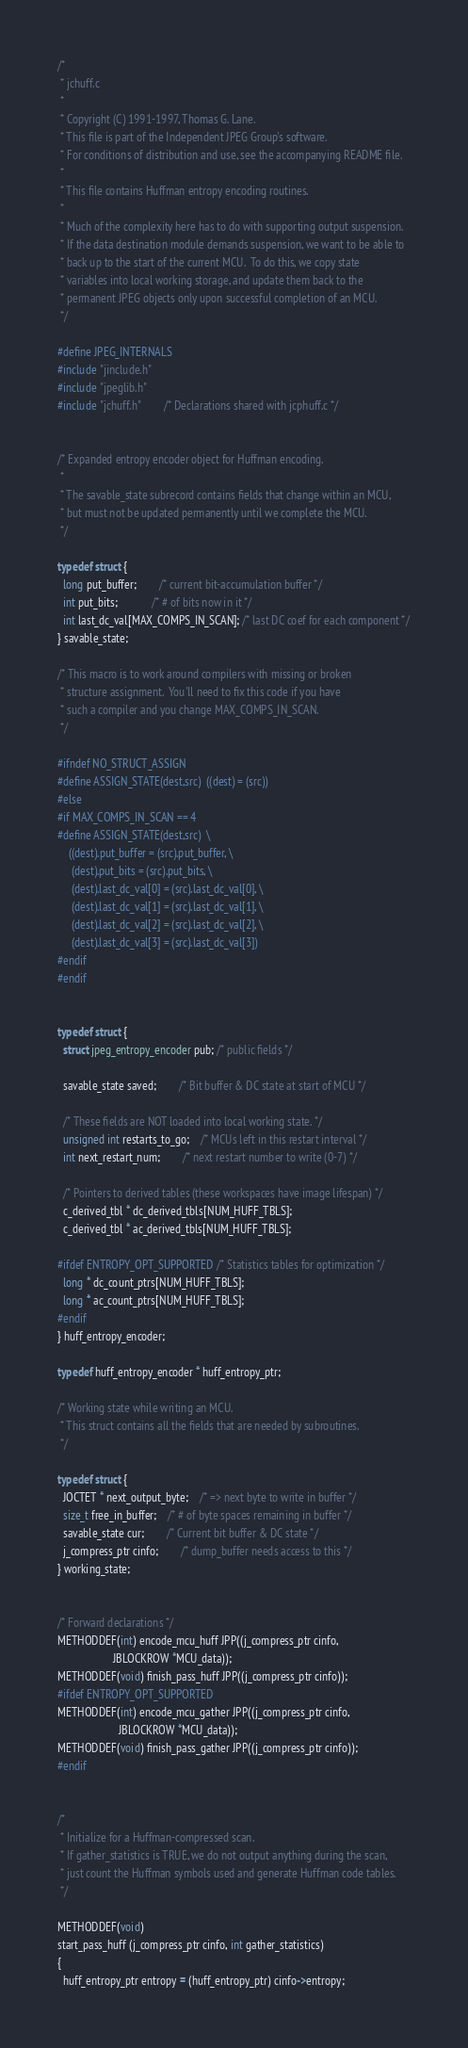<code> <loc_0><loc_0><loc_500><loc_500><_C++_>/*
 * jchuff.c
 *
 * Copyright (C) 1991-1997, Thomas G. Lane.
 * This file is part of the Independent JPEG Group's software.
 * For conditions of distribution and use, see the accompanying README file.
 *
 * This file contains Huffman entropy encoding routines.
 *
 * Much of the complexity here has to do with supporting output suspension.
 * If the data destination module demands suspension, we want to be able to
 * back up to the start of the current MCU.  To do this, we copy state
 * variables into local working storage, and update them back to the
 * permanent JPEG objects only upon successful completion of an MCU.
 */

#define JPEG_INTERNALS
#include "jinclude.h"
#include "jpeglib.h"
#include "jchuff.h"		/* Declarations shared with jcphuff.c */


/* Expanded entropy encoder object for Huffman encoding.
 *
 * The savable_state subrecord contains fields that change within an MCU,
 * but must not be updated permanently until we complete the MCU.
 */

typedef struct {
  long put_buffer;		/* current bit-accumulation buffer */
  int put_bits;			/* # of bits now in it */
  int last_dc_val[MAX_COMPS_IN_SCAN]; /* last DC coef for each component */
} savable_state;

/* This macro is to work around compilers with missing or broken
 * structure assignment.  You'll need to fix this code if you have
 * such a compiler and you change MAX_COMPS_IN_SCAN.
 */

#ifndef NO_STRUCT_ASSIGN
#define ASSIGN_STATE(dest,src)  ((dest) = (src))
#else
#if MAX_COMPS_IN_SCAN == 4
#define ASSIGN_STATE(dest,src)  \
	((dest).put_buffer = (src).put_buffer, \
	 (dest).put_bits = (src).put_bits, \
	 (dest).last_dc_val[0] = (src).last_dc_val[0], \
	 (dest).last_dc_val[1] = (src).last_dc_val[1], \
	 (dest).last_dc_val[2] = (src).last_dc_val[2], \
	 (dest).last_dc_val[3] = (src).last_dc_val[3])
#endif
#endif


typedef struct {
  struct jpeg_entropy_encoder pub; /* public fields */

  savable_state saved;		/* Bit buffer & DC state at start of MCU */

  /* These fields are NOT loaded into local working state. */
  unsigned int restarts_to_go;	/* MCUs left in this restart interval */
  int next_restart_num;		/* next restart number to write (0-7) */

  /* Pointers to derived tables (these workspaces have image lifespan) */
  c_derived_tbl * dc_derived_tbls[NUM_HUFF_TBLS];
  c_derived_tbl * ac_derived_tbls[NUM_HUFF_TBLS];

#ifdef ENTROPY_OPT_SUPPORTED	/* Statistics tables for optimization */
  long * dc_count_ptrs[NUM_HUFF_TBLS];
  long * ac_count_ptrs[NUM_HUFF_TBLS];
#endif
} huff_entropy_encoder;

typedef huff_entropy_encoder * huff_entropy_ptr;

/* Working state while writing an MCU.
 * This struct contains all the fields that are needed by subroutines.
 */

typedef struct {
  JOCTET * next_output_byte;	/* => next byte to write in buffer */
  size_t free_in_buffer;	/* # of byte spaces remaining in buffer */
  savable_state cur;		/* Current bit buffer & DC state */
  j_compress_ptr cinfo;		/* dump_buffer needs access to this */
} working_state;


/* Forward declarations */
METHODDEF(int) encode_mcu_huff JPP((j_compress_ptr cinfo,
					JBLOCKROW *MCU_data));
METHODDEF(void) finish_pass_huff JPP((j_compress_ptr cinfo));
#ifdef ENTROPY_OPT_SUPPORTED
METHODDEF(int) encode_mcu_gather JPP((j_compress_ptr cinfo,
					  JBLOCKROW *MCU_data));
METHODDEF(void) finish_pass_gather JPP((j_compress_ptr cinfo));
#endif


/*
 * Initialize for a Huffman-compressed scan.
 * If gather_statistics is TRUE, we do not output anything during the scan,
 * just count the Huffman symbols used and generate Huffman code tables.
 */

METHODDEF(void)
start_pass_huff (j_compress_ptr cinfo, int gather_statistics)
{
  huff_entropy_ptr entropy = (huff_entropy_ptr) cinfo->entropy;</code> 